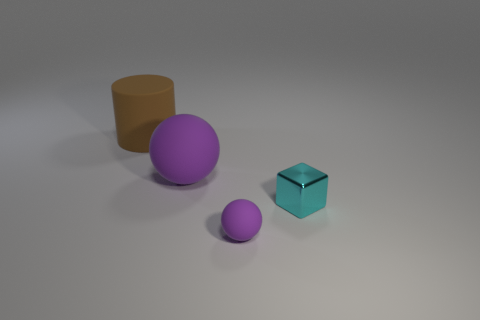Add 3 tiny shiny objects. How many objects exist? 7 Add 4 rubber cylinders. How many rubber cylinders are left? 5 Add 2 brown cylinders. How many brown cylinders exist? 3 Subtract 0 blue cubes. How many objects are left? 4 Subtract all cylinders. How many objects are left? 3 Subtract all brown cylinders. Subtract all large gray rubber blocks. How many objects are left? 3 